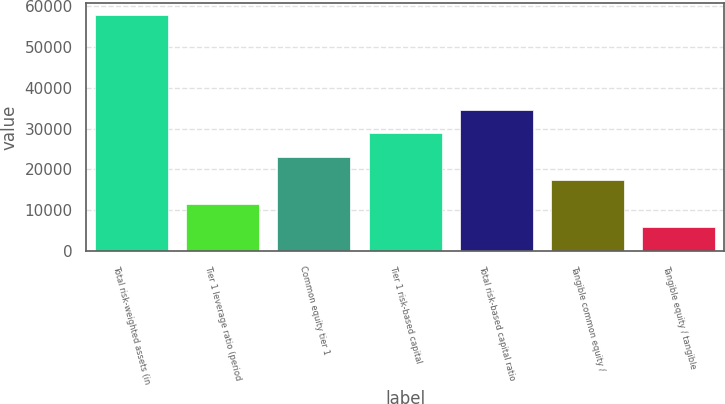<chart> <loc_0><loc_0><loc_500><loc_500><bar_chart><fcel>Total risk-weighted assets (in<fcel>Tier 1 leverage ratio (period<fcel>Common equity tier 1<fcel>Tier 1 risk-based capital<fcel>Total risk-based capital ratio<fcel>Tangible common equity /<fcel>Tangible equity / tangible<nl><fcel>57840<fcel>11574.4<fcel>23140.8<fcel>28924<fcel>34707.2<fcel>17357.6<fcel>5791.16<nl></chart> 